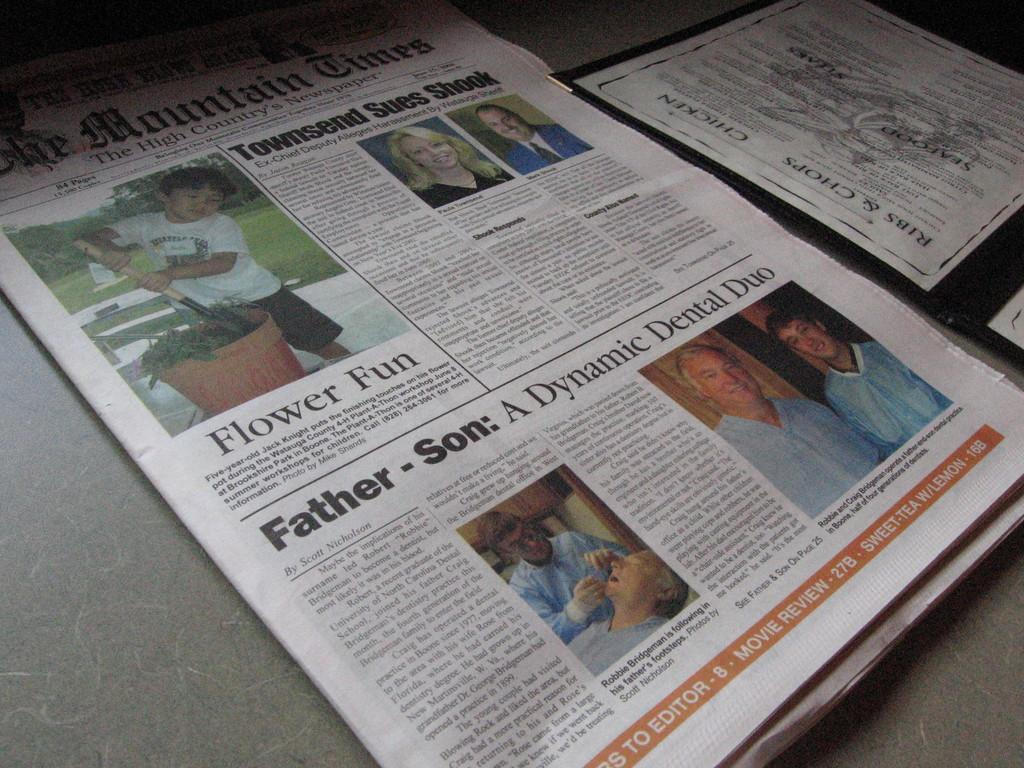<image>
Give a short and clear explanation of the subsequent image. A newspaper, :The MountainTimes, sits next to a menu on a table. 